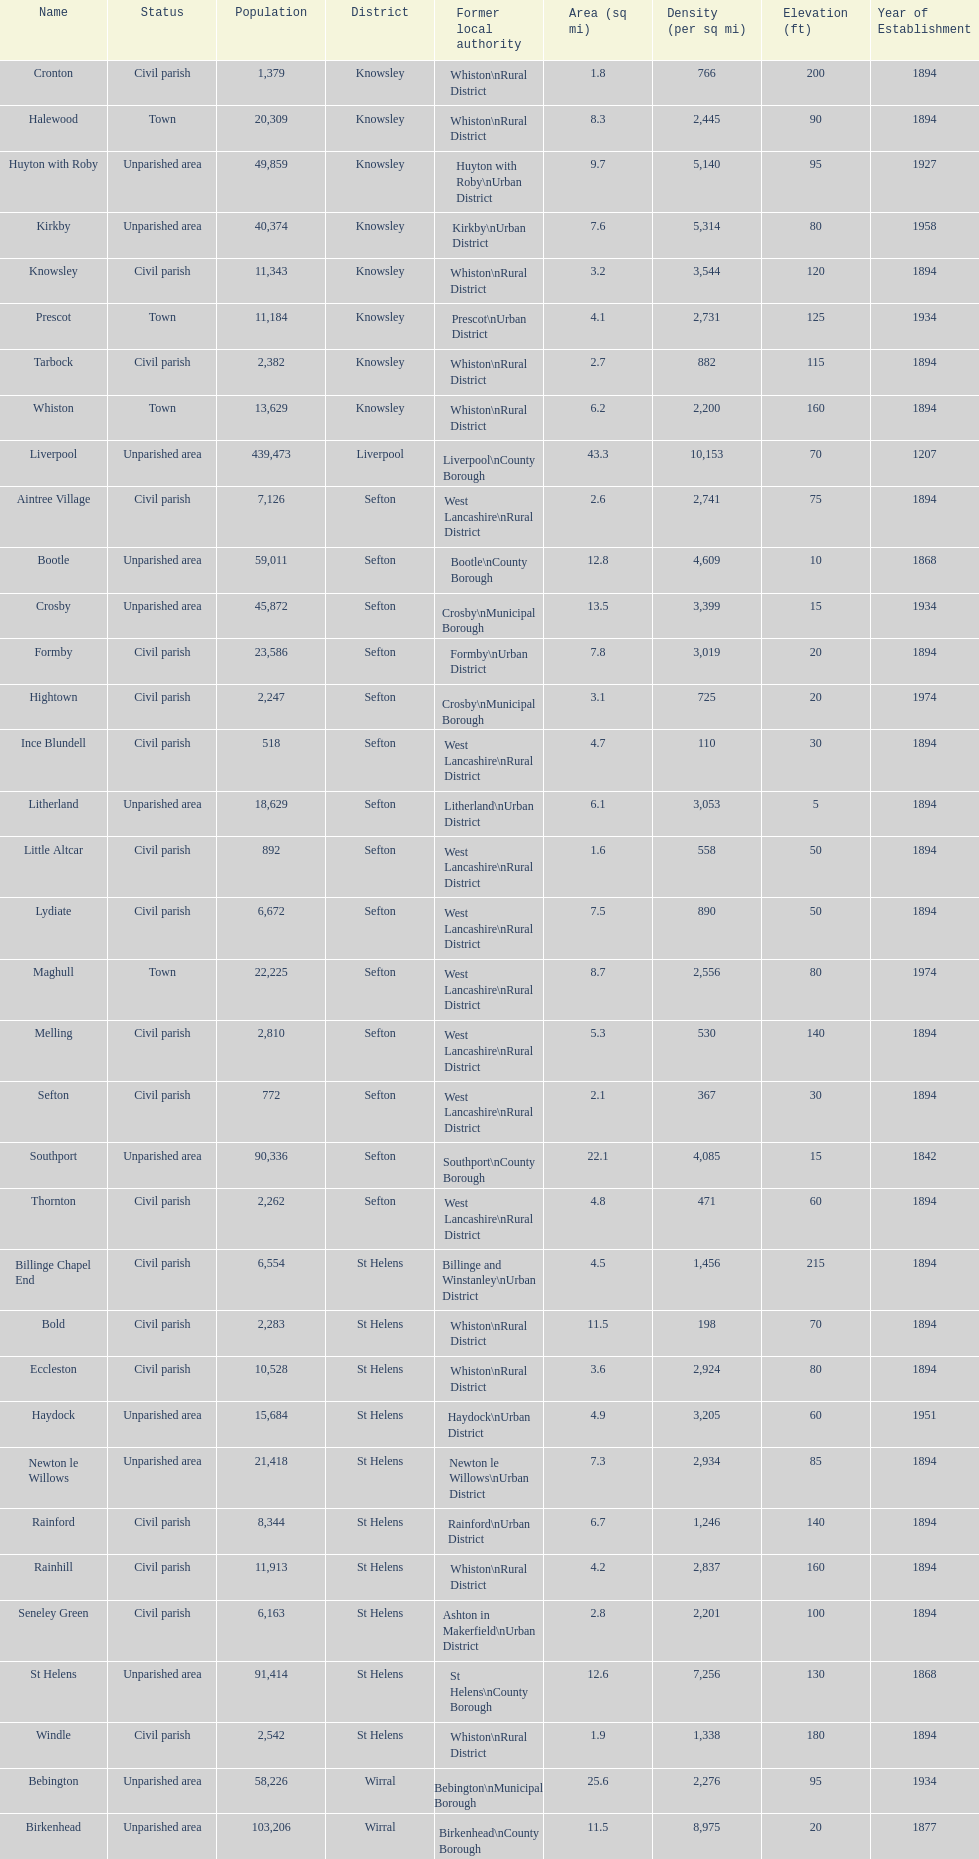Which area has the least number of residents? Ince Blundell. Could you parse the entire table? {'header': ['Name', 'Status', 'Population', 'District', 'Former local authority', 'Area (sq mi)', 'Density (per sq mi)', 'Elevation (ft)', 'Year of Establishment'], 'rows': [['Cronton', 'Civil parish', '1,379', 'Knowsley', 'Whiston\\nRural District', '1.8', '766', '200', '1894'], ['Halewood', 'Town', '20,309', 'Knowsley', 'Whiston\\nRural District', '8.3', '2,445', '90', '1894'], ['Huyton with Roby', 'Unparished area', '49,859', 'Knowsley', 'Huyton with Roby\\nUrban District', '9.7', '5,140', '95', '1927'], ['Kirkby', 'Unparished area', '40,374', 'Knowsley', 'Kirkby\\nUrban District', '7.6', '5,314', '80', '1958'], ['Knowsley', 'Civil parish', '11,343', 'Knowsley', 'Whiston\\nRural District', '3.2', '3,544', '120', '1894'], ['Prescot', 'Town', '11,184', 'Knowsley', 'Prescot\\nUrban District', '4.1', '2,731', '125', '1934'], ['Tarbock', 'Civil parish', '2,382', 'Knowsley', 'Whiston\\nRural District', '2.7', '882', '115', '1894'], ['Whiston', 'Town', '13,629', 'Knowsley', 'Whiston\\nRural District', '6.2', '2,200', '160', '1894'], ['Liverpool', 'Unparished area', '439,473', 'Liverpool', 'Liverpool\\nCounty Borough', '43.3', '10,153', '70', '1207'], ['Aintree Village', 'Civil parish', '7,126', 'Sefton', 'West Lancashire\\nRural District', '2.6', '2,741', '75', '1894'], ['Bootle', 'Unparished area', '59,011', 'Sefton', 'Bootle\\nCounty Borough', '12.8', '4,609', '10', '1868'], ['Crosby', 'Unparished area', '45,872', 'Sefton', 'Crosby\\nMunicipal Borough', '13.5', '3,399', '15', '1934'], ['Formby', 'Civil parish', '23,586', 'Sefton', 'Formby\\nUrban District', '7.8', '3,019', '20', '1894'], ['Hightown', 'Civil parish', '2,247', 'Sefton', 'Crosby\\nMunicipal Borough', '3.1', '725', '20', '1974'], ['Ince Blundell', 'Civil parish', '518', 'Sefton', 'West Lancashire\\nRural District', '4.7', '110', '30', '1894'], ['Litherland', 'Unparished area', '18,629', 'Sefton', 'Litherland\\nUrban District', '6.1', '3,053', '5', '1894'], ['Little Altcar', 'Civil parish', '892', 'Sefton', 'West Lancashire\\nRural District', '1.6', '558', '50', '1894'], ['Lydiate', 'Civil parish', '6,672', 'Sefton', 'West Lancashire\\nRural District', '7.5', '890', '50', '1894'], ['Maghull', 'Town', '22,225', 'Sefton', 'West Lancashire\\nRural District', '8.7', '2,556', '80', '1974'], ['Melling', 'Civil parish', '2,810', 'Sefton', 'West Lancashire\\nRural District', '5.3', '530', '140', '1894'], ['Sefton', 'Civil parish', '772', 'Sefton', 'West Lancashire\\nRural District', '2.1', '367', '30', '1894'], ['Southport', 'Unparished area', '90,336', 'Sefton', 'Southport\\nCounty Borough', '22.1', '4,085', '15', '1842'], ['Thornton', 'Civil parish', '2,262', 'Sefton', 'West Lancashire\\nRural District', '4.8', '471', '60', '1894'], ['Billinge Chapel End', 'Civil parish', '6,554', 'St Helens', 'Billinge and Winstanley\\nUrban District', '4.5', '1,456', '215', '1894'], ['Bold', 'Civil parish', '2,283', 'St Helens', 'Whiston\\nRural District', '11.5', '198', '70', '1894'], ['Eccleston', 'Civil parish', '10,528', 'St Helens', 'Whiston\\nRural District', '3.6', '2,924', '80', '1894'], ['Haydock', 'Unparished area', '15,684', 'St Helens', 'Haydock\\nUrban District', '4.9', '3,205', '60', '1951'], ['Newton le Willows', 'Unparished area', '21,418', 'St Helens', 'Newton le Willows\\nUrban District', '7.3', '2,934', '85', '1894'], ['Rainford', 'Civil parish', '8,344', 'St Helens', 'Rainford\\nUrban District', '6.7', '1,246', '140', '1894'], ['Rainhill', 'Civil parish', '11,913', 'St Helens', 'Whiston\\nRural District', '4.2', '2,837', '160', '1894'], ['Seneley Green', 'Civil parish', '6,163', 'St Helens', 'Ashton in Makerfield\\nUrban District', '2.8', '2,201', '100', '1894'], ['St Helens', 'Unparished area', '91,414', 'St Helens', 'St Helens\\nCounty Borough', '12.6', '7,256', '130', '1868'], ['Windle', 'Civil parish', '2,542', 'St Helens', 'Whiston\\nRural District', '1.9', '1,338', '180', '1894'], ['Bebington', 'Unparished area', '58,226', 'Wirral', 'Bebington\\nMunicipal Borough', '25.6', '2,276', '95', '1934'], ['Birkenhead', 'Unparished area', '103,206', 'Wirral', 'Birkenhead\\nCounty Borough', '11.5', '8,975', '20', '1877'], ['Heswall', 'Unparished area', '29,977', 'Wirral', 'Wirral\\nUrban District', '21.2', '1,414', '210', '1933'], ['Hoylake', 'Unparished area', '35,655', 'Wirral', 'Hoylake\\nUrban District', '17.9', '1,993', '30', '1894'], ['Wallasey', 'Unparished area', '84,348', 'Wirral', 'Wallasey\\nCounty Borough', '19.1', '4,418', '35', '1913']]} 